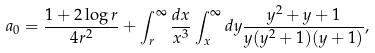<formula> <loc_0><loc_0><loc_500><loc_500>a _ { 0 } = \frac { 1 + 2 \log r } { 4 r ^ { 2 } } + \int _ { r } ^ { \infty } \frac { d x } { x ^ { 3 } } \int _ { x } ^ { \infty } d y \frac { y ^ { 2 } + y + 1 } { y ( y ^ { 2 } + 1 ) ( y + 1 ) } ,</formula> 